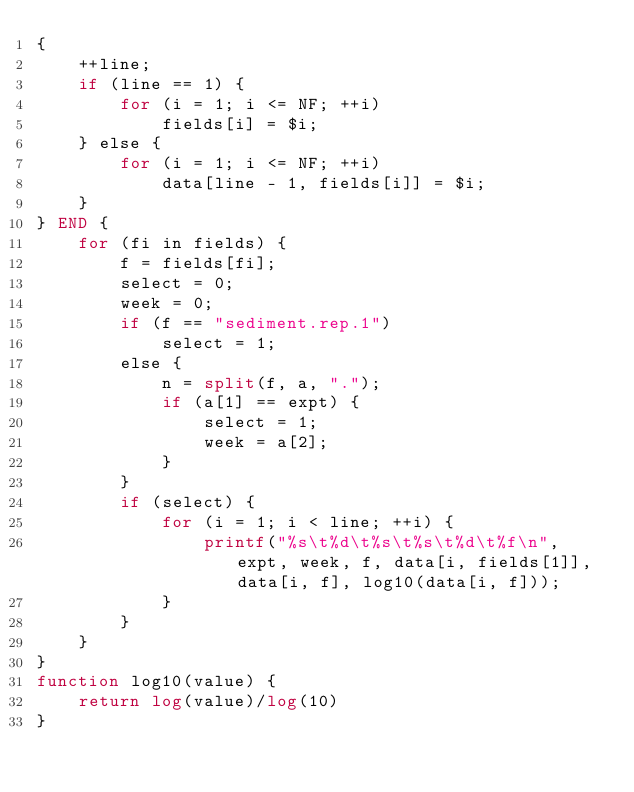<code> <loc_0><loc_0><loc_500><loc_500><_Awk_>{
	++line;
	if (line == 1) {
		for (i = 1; i <= NF; ++i)
			fields[i] = $i;
	} else {
		for (i = 1; i <= NF; ++i)
			data[line - 1, fields[i]] = $i;
	}
} END {
	for (fi in fields) {
		f = fields[fi];
		select = 0;
		week = 0;
		if (f == "sediment.rep.1")
			select = 1;
		else {
			n = split(f, a, ".");
			if (a[1] == expt) {
				select = 1;
				week = a[2];
			}
		}
		if (select) {
			for (i = 1; i < line; ++i) {
				printf("%s\t%d\t%s\t%s\t%d\t%f\n", expt, week, f, data[i, fields[1]], data[i, f], log10(data[i, f]));
			}
		}
	}
}
function log10(value) {
	return log(value)/log(10)
}
</code> 